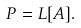Convert formula to latex. <formula><loc_0><loc_0><loc_500><loc_500>P = L [ A ] .</formula> 